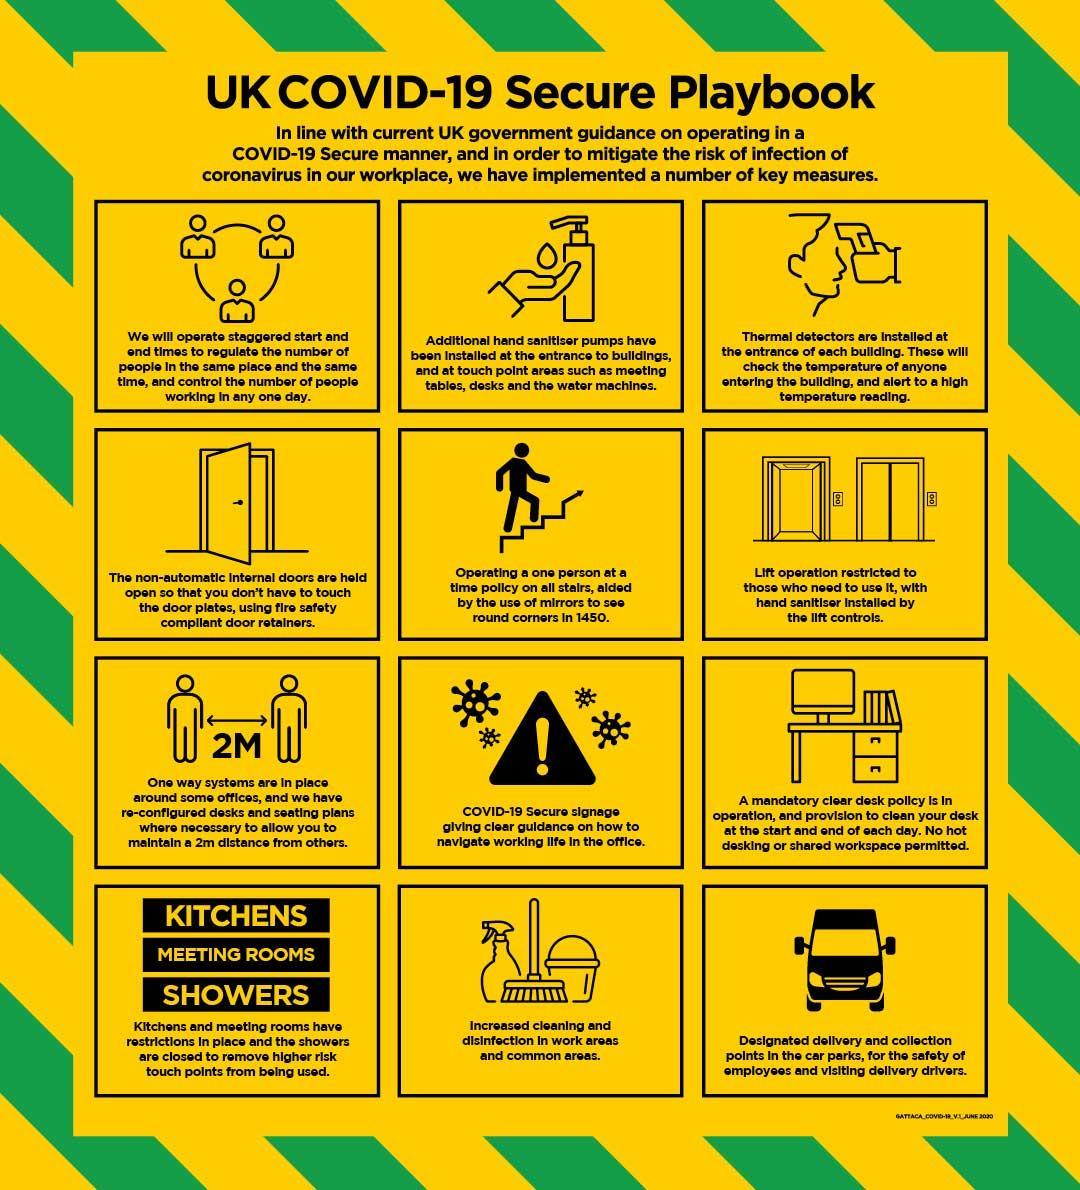What is the name of the equipment to check the temperature of people?
Answer the question with a short phrase. Thermal Detectors How many key measures are listed in the info graphic? 12 Why mirrors are used in staircase? to see round corners in 1450 